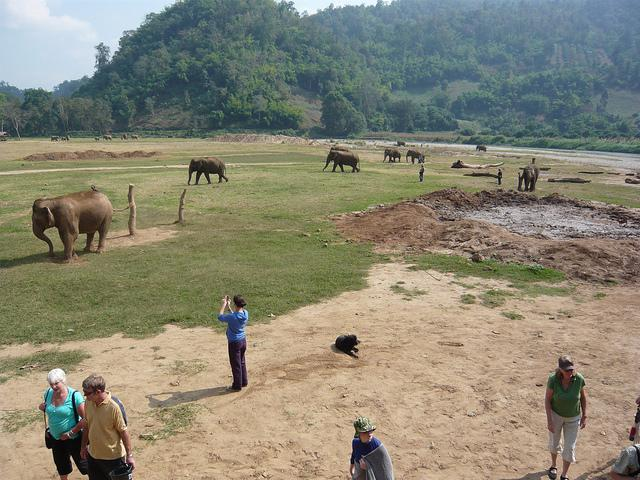The person holding the camera is wearing what color shirt?

Choices:
A) orange
B) yellow
C) blue
D) red blue 